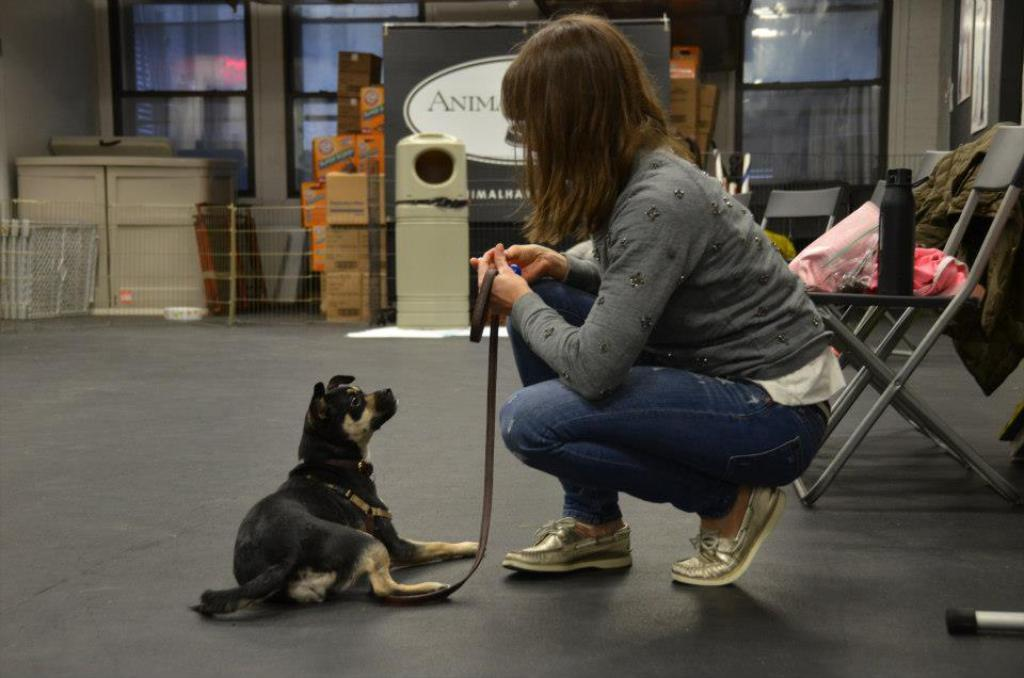Who is present in the image? There is a person in the image. What animal is with the person? The person is with a dog. What can be seen on the chair in the image? There are objects on a chair in the image. What type of furniture is visible in the background? There are cupboards in the background of the image. What else can be seen in the background? There is a board in the background of the image. What type of juice is being served on the board in the image? There is no juice or board serving juice present in the image. 